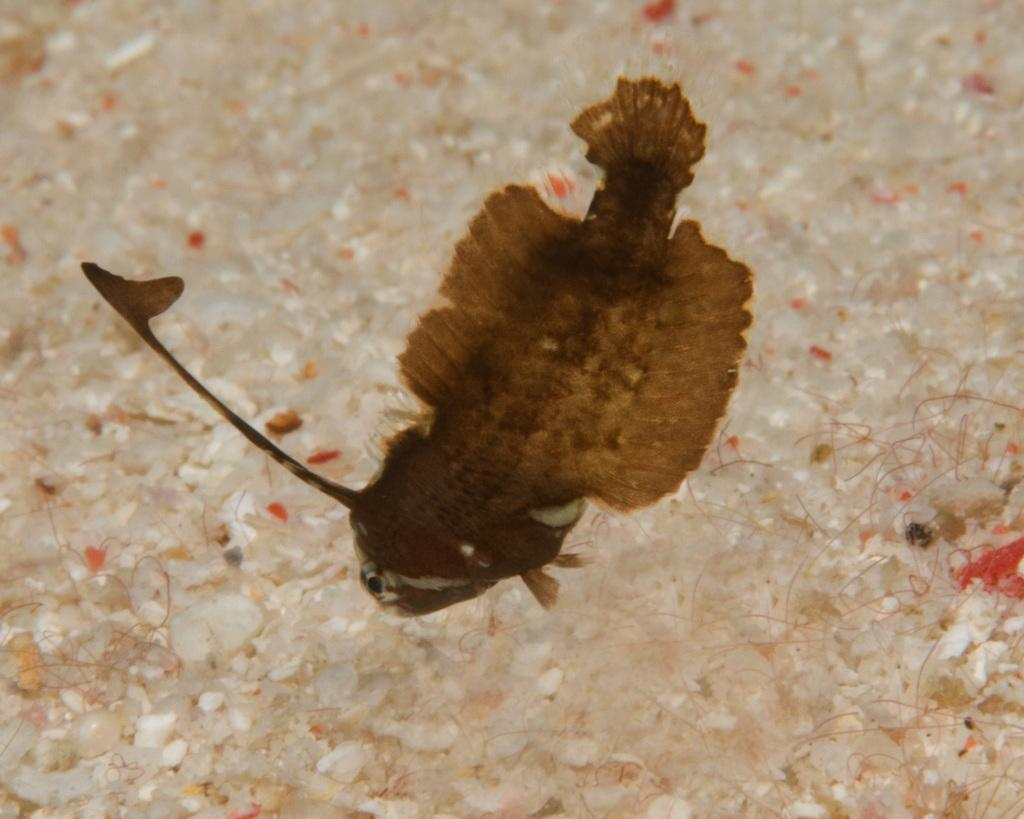What type of animal is in the image? There is a fish in the image. What color is the fish? The fish is brown in color. What type of jar is the fish swimming in the image? There is no jar present in the image; the fish is not in a jar. 